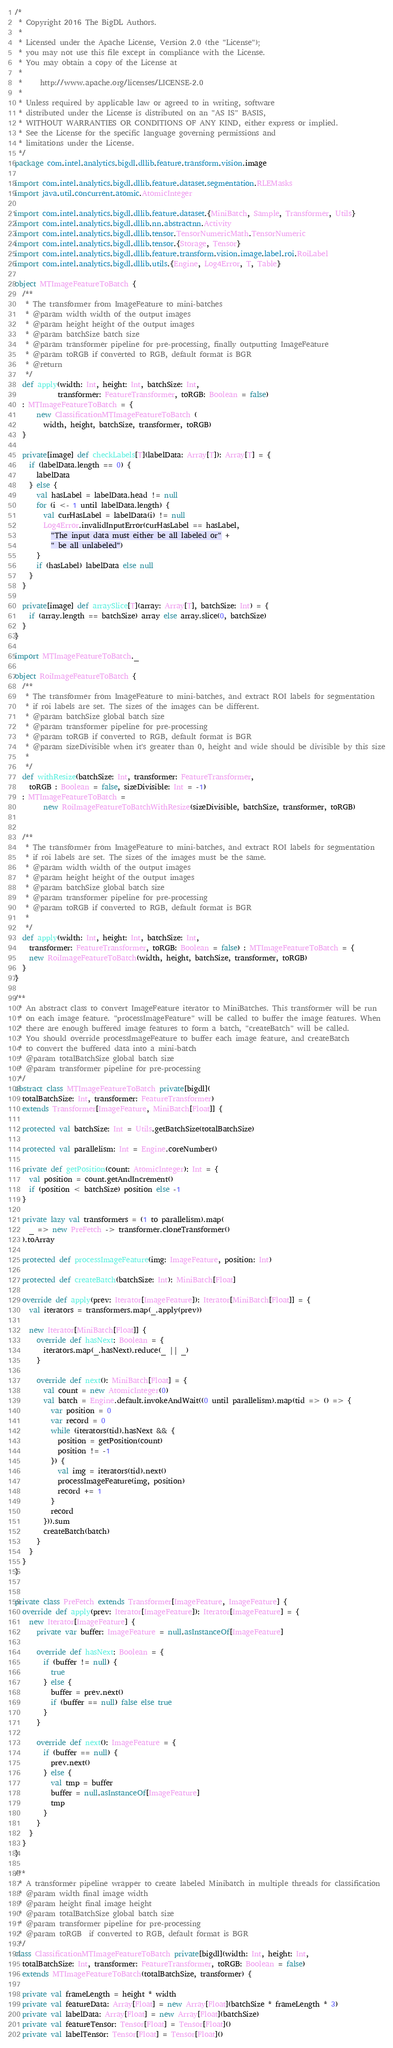Convert code to text. <code><loc_0><loc_0><loc_500><loc_500><_Scala_>/*
 * Copyright 2016 The BigDL Authors.
 *
 * Licensed under the Apache License, Version 2.0 (the "License");
 * you may not use this file except in compliance with the License.
 * You may obtain a copy of the License at
 *
 *     http://www.apache.org/licenses/LICENSE-2.0
 *
 * Unless required by applicable law or agreed to in writing, software
 * distributed under the License is distributed on an "AS IS" BASIS,
 * WITHOUT WARRANTIES OR CONDITIONS OF ANY KIND, either express or implied.
 * See the License for the specific language governing permissions and
 * limitations under the License.
 */
package com.intel.analytics.bigdl.dllib.feature.transform.vision.image

import com.intel.analytics.bigdl.dllib.feature.dataset.segmentation.RLEMasks
import java.util.concurrent.atomic.AtomicInteger

import com.intel.analytics.bigdl.dllib.feature.dataset.{MiniBatch, Sample, Transformer, Utils}
import com.intel.analytics.bigdl.dllib.nn.abstractnn.Activity
import com.intel.analytics.bigdl.dllib.tensor.TensorNumericMath.TensorNumeric
import com.intel.analytics.bigdl.dllib.tensor.{Storage, Tensor}
import com.intel.analytics.bigdl.dllib.feature.transform.vision.image.label.roi.RoiLabel
import com.intel.analytics.bigdl.dllib.utils.{Engine, Log4Error, T, Table}

object MTImageFeatureToBatch {
  /**
   * The transformer from ImageFeature to mini-batches
   * @param width width of the output images
   * @param height height of the output images
   * @param batchSize batch size
   * @param transformer pipeline for pre-processing, finally outputting ImageFeature
   * @param toRGB if converted to RGB, default format is BGR
   * @return
   */
  def apply(width: Int, height: Int, batchSize: Int,
            transformer: FeatureTransformer, toRGB: Boolean = false)
  : MTImageFeatureToBatch = {
      new ClassificationMTImageFeatureToBatch (
        width, height, batchSize, transformer, toRGB)
  }

  private[image] def checkLabels[T](labelData: Array[T]): Array[T] = {
    if (labelData.length == 0) {
      labelData
    } else {
      val hasLabel = labelData.head != null
      for (i <- 1 until labelData.length) {
        val curHasLabel = labelData(i) != null
        Log4Error.invalidInputError(curHasLabel == hasLabel,
          "The input data must either be all labeled or" +
          " be all unlabeled")
      }
      if (hasLabel) labelData else null
    }
  }

  private[image] def arraySlice[T](array: Array[T], batchSize: Int) = {
    if (array.length == batchSize) array else array.slice(0, batchSize)
  }
}

import MTImageFeatureToBatch._

object RoiImageFeatureToBatch {
  /**
   * The transformer from ImageFeature to mini-batches, and extract ROI labels for segmentation
   * if roi labels are set. The sizes of the images can be different.
   * @param batchSize global batch size
   * @param transformer pipeline for pre-processing
   * @param toRGB if converted to RGB, default format is BGR
   * @param sizeDivisible when it's greater than 0, height and wide should be divisible by this size
   *
   */
  def withResize(batchSize: Int, transformer: FeatureTransformer,
    toRGB : Boolean = false, sizeDivisible: Int = -1)
  : MTImageFeatureToBatch =
        new RoiImageFeatureToBatchWithResize(sizeDivisible, batchSize, transformer, toRGB)


  /**
   * The transformer from ImageFeature to mini-batches, and extract ROI labels for segmentation
   * if roi labels are set. The sizes of the images must be the same.
   * @param width width of the output images
   * @param height height of the output images
   * @param batchSize global batch size
   * @param transformer pipeline for pre-processing
   * @param toRGB if converted to RGB, default format is BGR
   *
   */
  def apply(width: Int, height: Int, batchSize: Int,
    transformer: FeatureTransformer, toRGB: Boolean = false) : MTImageFeatureToBatch = {
    new RoiImageFeatureToBatch(width, height, batchSize, transformer, toRGB)
  }
}

/**
 * An abstract class to convert ImageFeature iterator to MiniBatches. This transformer will be run
 * on each image feature. "processImageFeature" will be called to buffer the image features. When
 * there are enough buffered image features to form a batch, "createBatch" will be called.
 * You should override processImageFeature to buffer each image feature, and createBatch
 * to convert the buffered data into a mini-batch
 * @param totalBatchSize global batch size
 * @param transformer pipeline for pre-processing
 */
abstract class MTImageFeatureToBatch private[bigdl](
  totalBatchSize: Int, transformer: FeatureTransformer)
  extends Transformer[ImageFeature, MiniBatch[Float]] {

  protected val batchSize: Int = Utils.getBatchSize(totalBatchSize)

  protected val parallelism: Int = Engine.coreNumber()

  private def getPosition(count: AtomicInteger): Int = {
    val position = count.getAndIncrement()
    if (position < batchSize) position else -1
  }

  private lazy val transformers = (1 to parallelism).map(
    _ => new PreFetch -> transformer.cloneTransformer()
  ).toArray

  protected def processImageFeature(img: ImageFeature, position: Int)

  protected def createBatch(batchSize: Int): MiniBatch[Float]

  override def apply(prev: Iterator[ImageFeature]): Iterator[MiniBatch[Float]] = {
    val iterators = transformers.map(_.apply(prev))

    new Iterator[MiniBatch[Float]] {
      override def hasNext: Boolean = {
        iterators.map(_.hasNext).reduce(_ || _)
      }

      override def next(): MiniBatch[Float] = {
        val count = new AtomicInteger(0)
        val batch = Engine.default.invokeAndWait((0 until parallelism).map(tid => () => {
          var position = 0
          var record = 0
          while (iterators(tid).hasNext && {
            position = getPosition(count)
            position != -1
          }) {
            val img = iterators(tid).next()
            processImageFeature(img, position)
            record += 1
          }
          record
        })).sum
        createBatch(batch)
      }
    }
  }
}


private class PreFetch extends Transformer[ImageFeature, ImageFeature] {
  override def apply(prev: Iterator[ImageFeature]): Iterator[ImageFeature] = {
    new Iterator[ImageFeature] {
      private var buffer: ImageFeature = null.asInstanceOf[ImageFeature]

      override def hasNext: Boolean = {
        if (buffer != null) {
          true
        } else {
          buffer = prev.next()
          if (buffer == null) false else true
        }
      }

      override def next(): ImageFeature = {
        if (buffer == null) {
          prev.next()
        } else {
          val tmp = buffer
          buffer = null.asInstanceOf[ImageFeature]
          tmp
        }
      }
    }
  }
}

/**
 * A transformer pipeline wrapper to create labeled Minibatch in multiple threads for classification
 * @param width final image width
 * @param height final image height
 * @param totalBatchSize global batch size
 * @param transformer pipeline for pre-processing
 * @param toRGB  if converted to RGB, default format is BGR
 */
class ClassificationMTImageFeatureToBatch private[bigdl](width: Int, height: Int,
  totalBatchSize: Int, transformer: FeatureTransformer, toRGB: Boolean = false)
  extends MTImageFeatureToBatch(totalBatchSize, transformer) {

  private val frameLength = height * width
  private val featureData: Array[Float] = new Array[Float](batchSize * frameLength * 3)
  private val labelData: Array[Float] = new Array[Float](batchSize)
  private val featureTensor: Tensor[Float] = Tensor[Float]()
  private val labelTensor: Tensor[Float] = Tensor[Float]()
</code> 